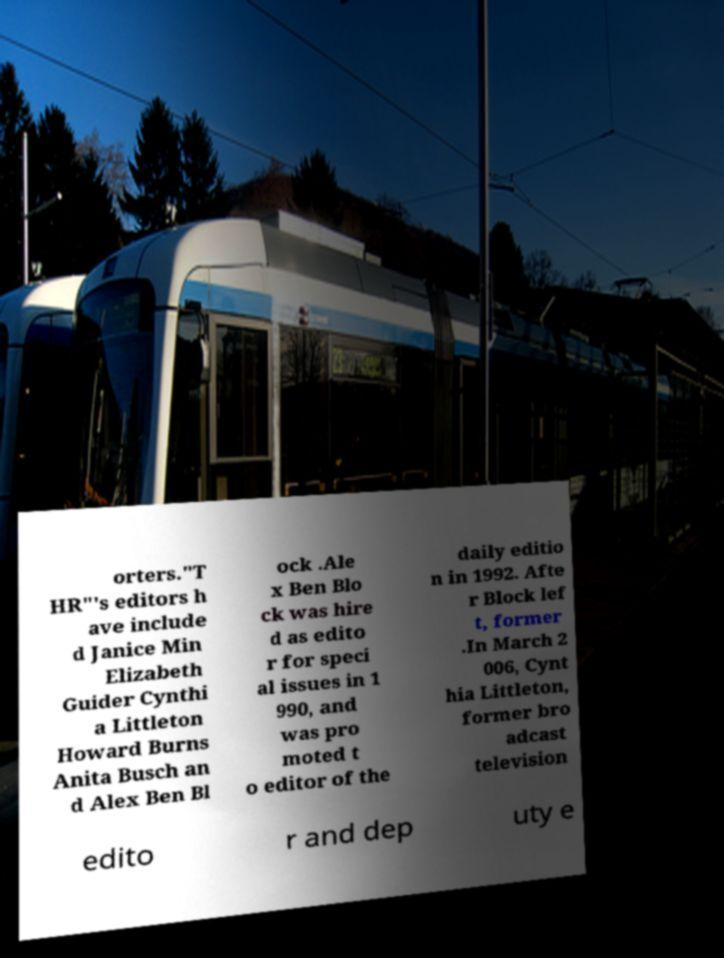Could you extract and type out the text from this image? orters."T HR"'s editors h ave include d Janice Min Elizabeth Guider Cynthi a Littleton Howard Burns Anita Busch an d Alex Ben Bl ock .Ale x Ben Blo ck was hire d as edito r for speci al issues in 1 990, and was pro moted t o editor of the daily editio n in 1992. Afte r Block lef t, former .In March 2 006, Cynt hia Littleton, former bro adcast television edito r and dep uty e 